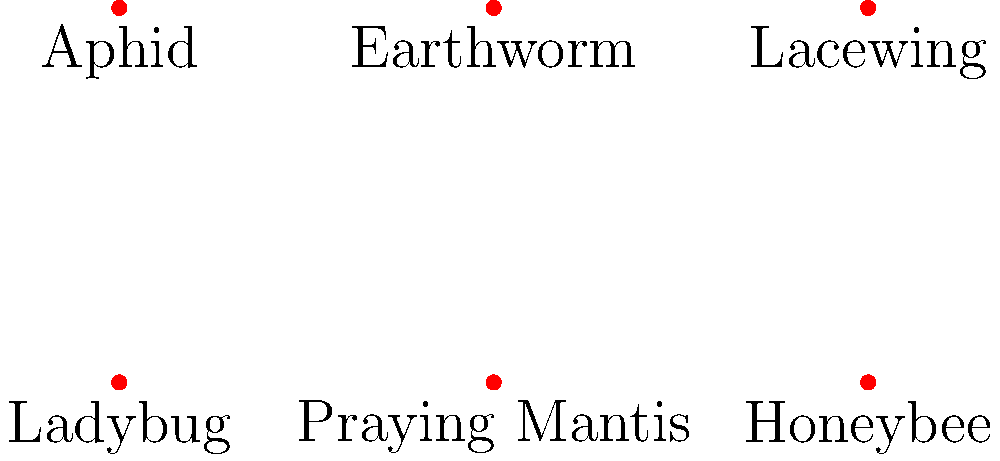Which of the insects illustrated above are considered beneficial for sustainable gardens and why? To identify beneficial insects for sustainable gardens, we need to consider their roles in the ecosystem:

1. Ladybug: Beneficial. They are predators that feed on aphids and other small pests, providing natural pest control.

2. Praying Mantis: Beneficial. They are generalist predators that eat a variety of garden pests, including flies, crickets, and moths.

3. Honeybee: Beneficial. They are crucial pollinators, essential for the reproduction of many plants and crop production.

4. Aphid: Not beneficial. They are pests that feed on plant sap and can damage crops.

5. Earthworm: Beneficial. They improve soil structure, aeration, and nutrient cycling through their burrowing and feeding activities.

6. Lacewing: Beneficial. Their larvae, known as "aphid lions," are voracious predators of aphids and other soft-bodied insects.

In sustainable gardening, we aim to encourage beneficial insects that provide natural pest control and pollination services, reducing the need for chemical interventions.
Answer: Ladybug, Praying Mantis, Honeybee, Earthworm, Lacewing 